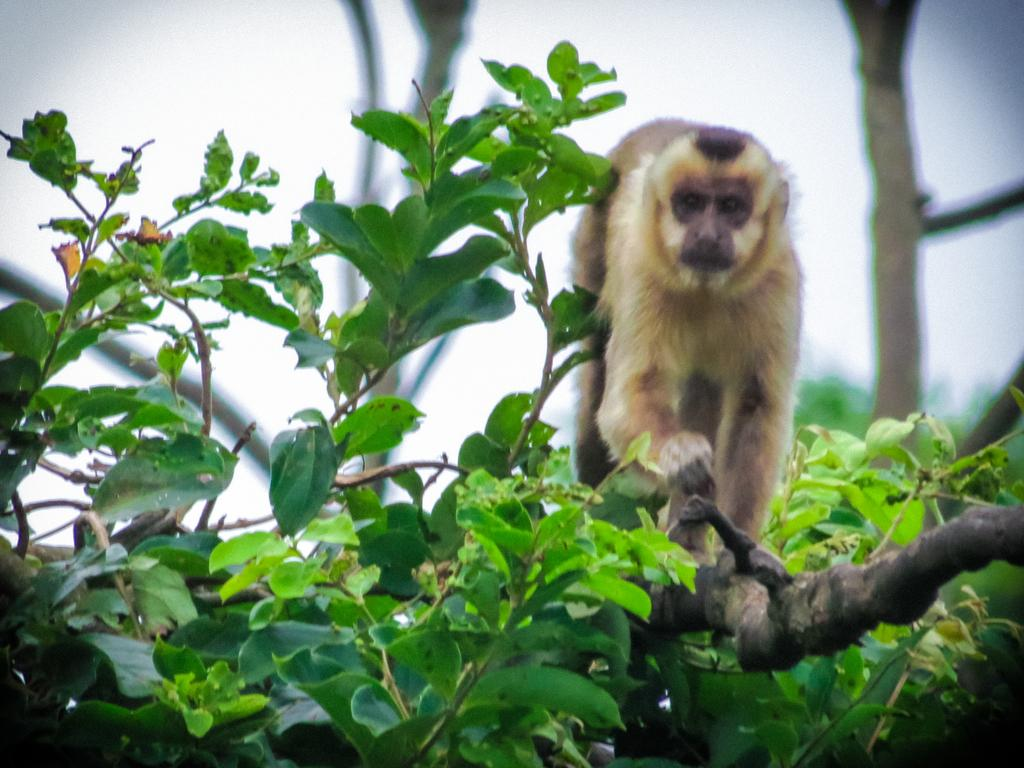What animal is present in the image? There is a monkey in the image. Where is the monkey located? The monkey is standing on a branch of a tree. Can you describe the background of the image? The background of the image is blurred. What type of grip does the toad have on the branch in the image? There is no toad present in the image; it features a monkey standing on a branch. 